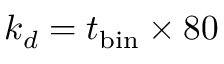Convert formula to latex. <formula><loc_0><loc_0><loc_500><loc_500>k _ { d } = t _ { b i n } \times 8 0</formula> 